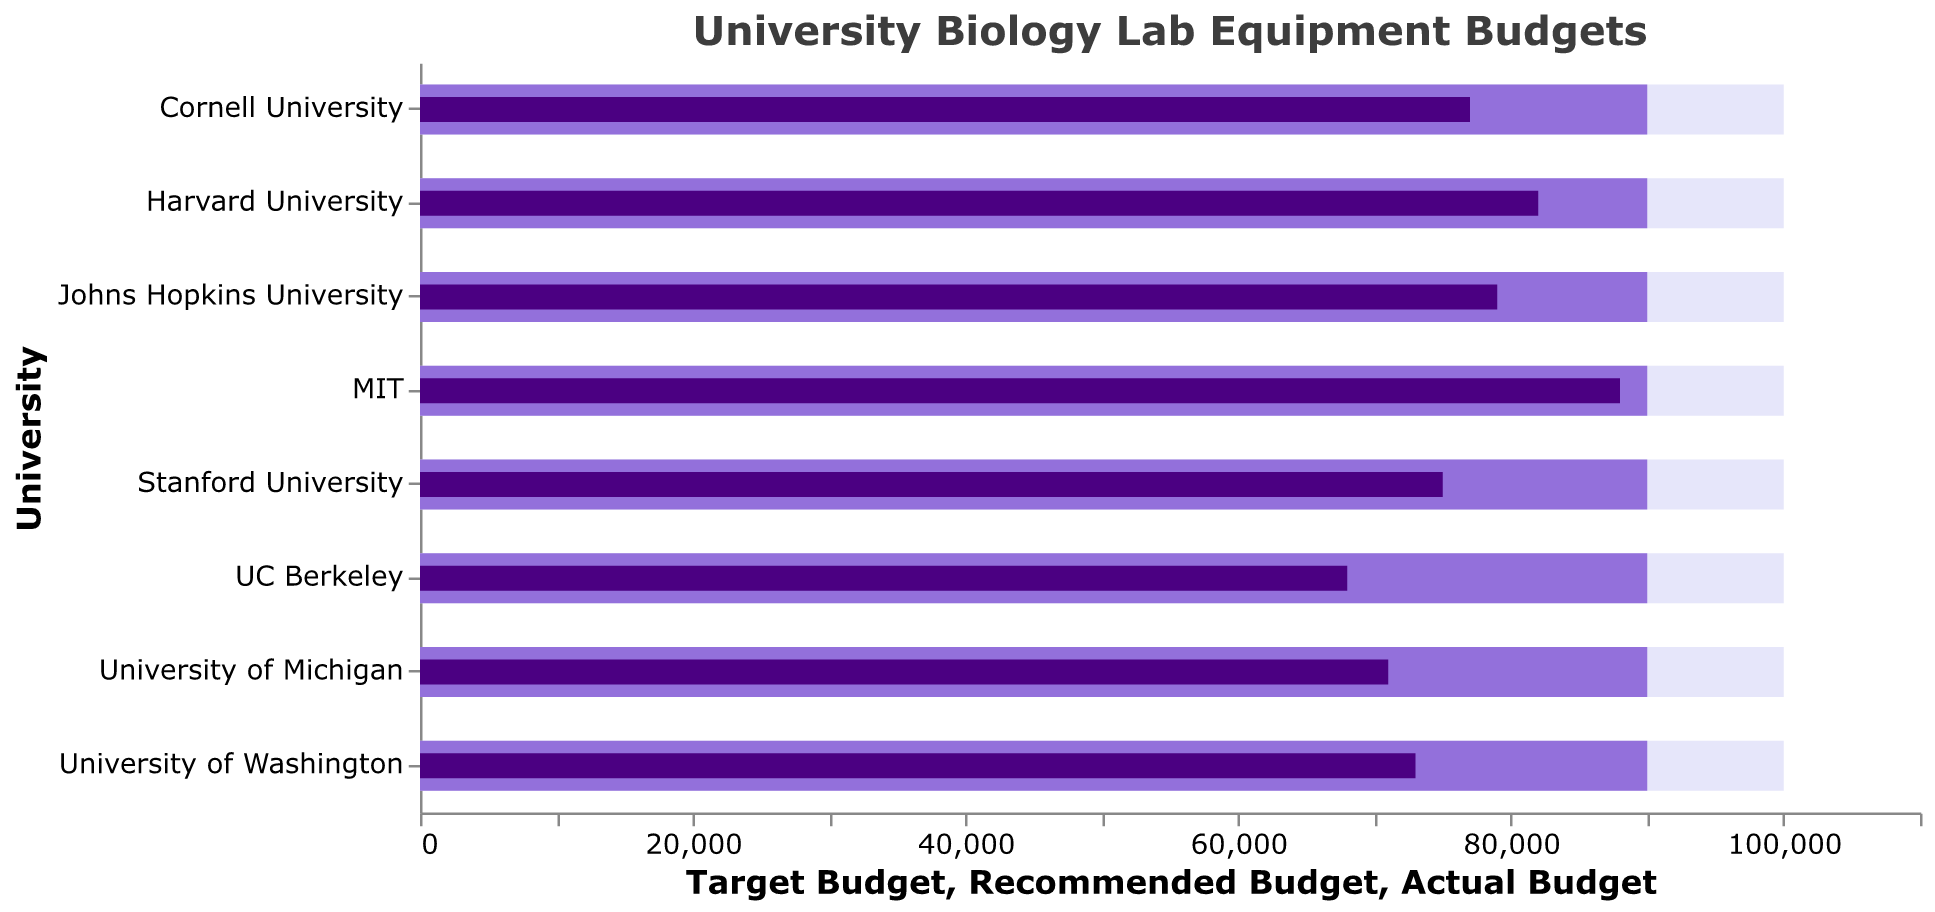What does the figure's title indicate? The title at the top of the figure states "University Biology Lab Equipment Budgets," implying that the plot compares the budgets of various university biology labs.
Answer: University Biology Lab Equipment Budgets Which university has the lowest actual budget? By looking at the shortest dark purple bar (actual budget), UC Berkeley has the lowest actual budget.
Answer: UC Berkeley What's the actual budget for Harvard University? The dark purple bar for Harvard University corresponds to an actual budget of $82,000.
Answer: $82,000 How does Stanford University’s actual budget compare to the recommended budget? The dark purple bar for Stanford University ($75,000) is shorter than the light purple bar representing the recommended budget ($90,000).
Answer: Lower Is there any university that meets or exceeds the recommended budget? None of the dark purple bars (actual budgets) reach the length of the light purple bars (recommended budgets).
Answer: No What is the average actual budget across all universities? Sum of actual budgets across all universities: 75,000 + 82,000 + 88,000 + 68,000 + 79,000 + 71,000 + 77,000 + 73,000 = 613,000. There are 8 universities, so the average actual budget is 613,000 / 8 = 76,625.
Answer: $76,625 Which university has the smallest difference between its actual and recommended budget? The difference for each university: Stanford University: 90,000-75,000=15,000, Harvard University: 90,000-82,000=8,000, MIT: 90,000-88,000=2,000, UC Berkeley: 90,000-68,000=22,000, Johns Hopkins University: 90,000-79,000=11,000, University of Michigan: 90,000-71,000=19,000, Cornell University: 90,000-77,000=13,000, University of Washington: 90,000-73,000=17,000. MIT has the smallest difference.
Answer: MIT What is the total recommended budget across all universities? Sum of the recommended budgets across all universities: 90,000 + 90,000 + 90,000 + 90,000 + 90,000 + 90,000 + 90,000 + 90,000 = 720,000.
Answer: $720,000 Which universities' actual budgets are within $10,000 of their target budgets? Universities with actual budgets (dark purple) close to target budgets (outer bar): Stanford University: 75,000 (100,000-75,000=25,000), Harvard University: 82,000 (100,000-82,000=18,000), MIT: 88,000 (100,000-88,000=12,000), UC Berkeley: 68,000 (100,000-68,000=32,000), Johns Hopkins University: 79,000 (100,000-79,000=21,000), University of Michigan: 71,000 (100,000-71,000=29,000), Cornell University: 77,000 (100,000-77,000=23,000), University of Washington: 73,000 (100,000-73,000=27,000). None are within $10,000.
Answer: None 